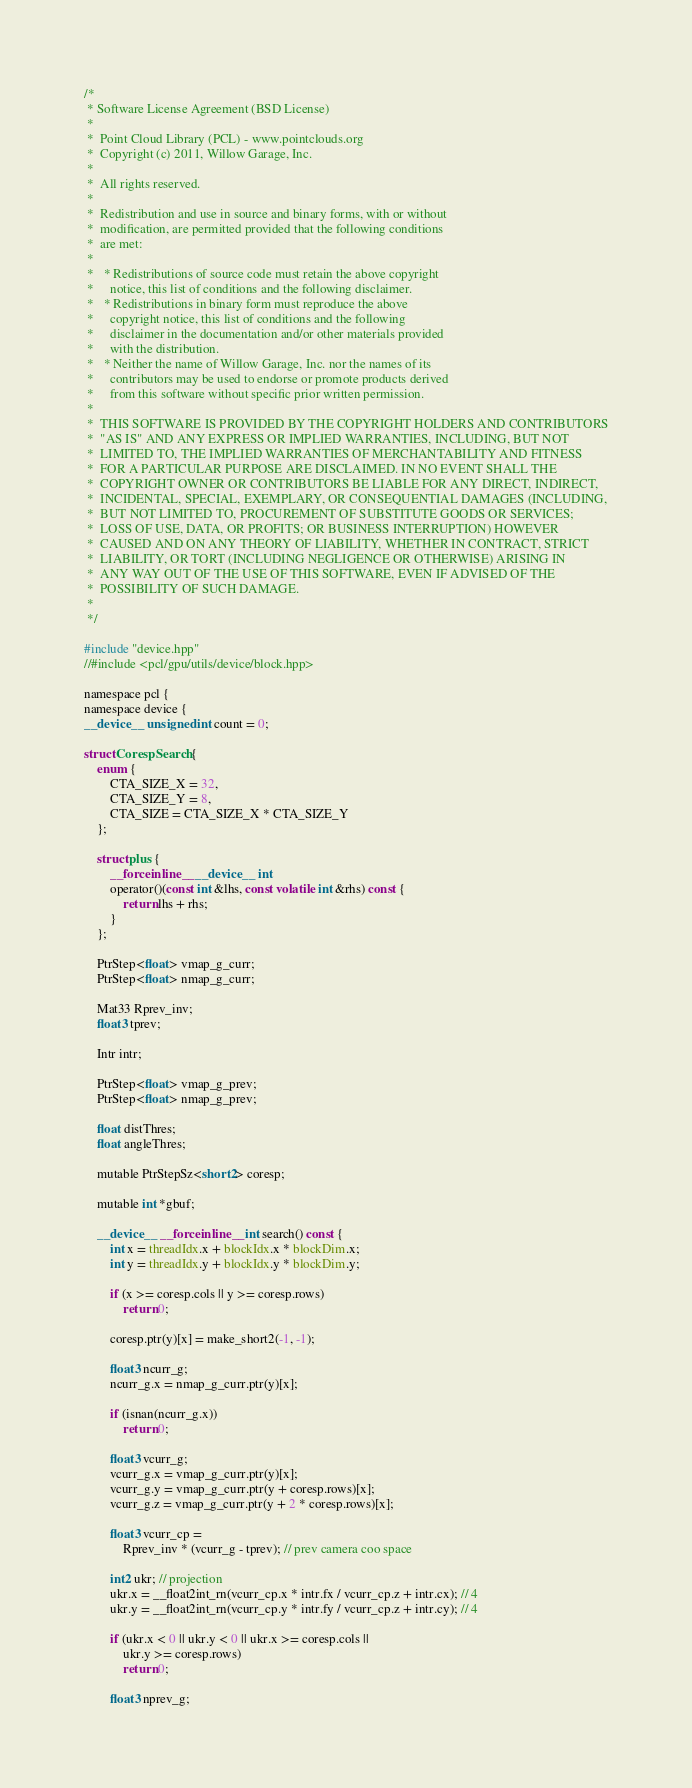Convert code to text. <code><loc_0><loc_0><loc_500><loc_500><_Cuda_>/*
 * Software License Agreement (BSD License)
 *
 *  Point Cloud Library (PCL) - www.pointclouds.org
 *  Copyright (c) 2011, Willow Garage, Inc.
 *
 *  All rights reserved.
 *
 *  Redistribution and use in source and binary forms, with or without
 *  modification, are permitted provided that the following conditions
 *  are met:
 *
 *   * Redistributions of source code must retain the above copyright
 *     notice, this list of conditions and the following disclaimer.
 *   * Redistributions in binary form must reproduce the above
 *     copyright notice, this list of conditions and the following
 *     disclaimer in the documentation and/or other materials provided
 *     with the distribution.
 *   * Neither the name of Willow Garage, Inc. nor the names of its
 *     contributors may be used to endorse or promote products derived
 *     from this software without specific prior written permission.
 *
 *  THIS SOFTWARE IS PROVIDED BY THE COPYRIGHT HOLDERS AND CONTRIBUTORS
 *  "AS IS" AND ANY EXPRESS OR IMPLIED WARRANTIES, INCLUDING, BUT NOT
 *  LIMITED TO, THE IMPLIED WARRANTIES OF MERCHANTABILITY AND FITNESS
 *  FOR A PARTICULAR PURPOSE ARE DISCLAIMED. IN NO EVENT SHALL THE
 *  COPYRIGHT OWNER OR CONTRIBUTORS BE LIABLE FOR ANY DIRECT, INDIRECT,
 *  INCIDENTAL, SPECIAL, EXEMPLARY, OR CONSEQUENTIAL DAMAGES (INCLUDING,
 *  BUT NOT LIMITED TO, PROCUREMENT OF SUBSTITUTE GOODS OR SERVICES;
 *  LOSS OF USE, DATA, OR PROFITS; OR BUSINESS INTERRUPTION) HOWEVER
 *  CAUSED AND ON ANY THEORY OF LIABILITY, WHETHER IN CONTRACT, STRICT
 *  LIABILITY, OR TORT (INCLUDING NEGLIGENCE OR OTHERWISE) ARISING IN
 *  ANY WAY OUT OF THE USE OF THIS SOFTWARE, EVEN IF ADVISED OF THE
 *  POSSIBILITY OF SUCH DAMAGE.
 *
 */

#include "device.hpp"
//#include <pcl/gpu/utils/device/block.hpp>

namespace pcl {
namespace device {
__device__ unsigned int count = 0;

struct CorespSearch {
    enum {
        CTA_SIZE_X = 32,
        CTA_SIZE_Y = 8,
        CTA_SIZE = CTA_SIZE_X * CTA_SIZE_Y
    };

    struct plus {
        __forceinline__ __device__ int
        operator()(const int &lhs, const volatile int &rhs) const {
            return lhs + rhs;
        }
    };

    PtrStep<float> vmap_g_curr;
    PtrStep<float> nmap_g_curr;

    Mat33 Rprev_inv;
    float3 tprev;

    Intr intr;

    PtrStep<float> vmap_g_prev;
    PtrStep<float> nmap_g_prev;

    float distThres;
    float angleThres;

    mutable PtrStepSz<short2> coresp;

    mutable int *gbuf;

    __device__ __forceinline__ int search() const {
        int x = threadIdx.x + blockIdx.x * blockDim.x;
        int y = threadIdx.y + blockIdx.y * blockDim.y;

        if (x >= coresp.cols || y >= coresp.rows)
            return 0;

        coresp.ptr(y)[x] = make_short2(-1, -1);

        float3 ncurr_g;
        ncurr_g.x = nmap_g_curr.ptr(y)[x];

        if (isnan(ncurr_g.x))
            return 0;

        float3 vcurr_g;
        vcurr_g.x = vmap_g_curr.ptr(y)[x];
        vcurr_g.y = vmap_g_curr.ptr(y + coresp.rows)[x];
        vcurr_g.z = vmap_g_curr.ptr(y + 2 * coresp.rows)[x];

        float3 vcurr_cp =
            Rprev_inv * (vcurr_g - tprev); // prev camera coo space

        int2 ukr; // projection
        ukr.x = __float2int_rn(vcurr_cp.x * intr.fx / vcurr_cp.z + intr.cx); // 4
        ukr.y = __float2int_rn(vcurr_cp.y * intr.fy / vcurr_cp.z + intr.cy); // 4

        if (ukr.x < 0 || ukr.y < 0 || ukr.x >= coresp.cols ||
            ukr.y >= coresp.rows)
            return 0;

        float3 nprev_g;</code> 